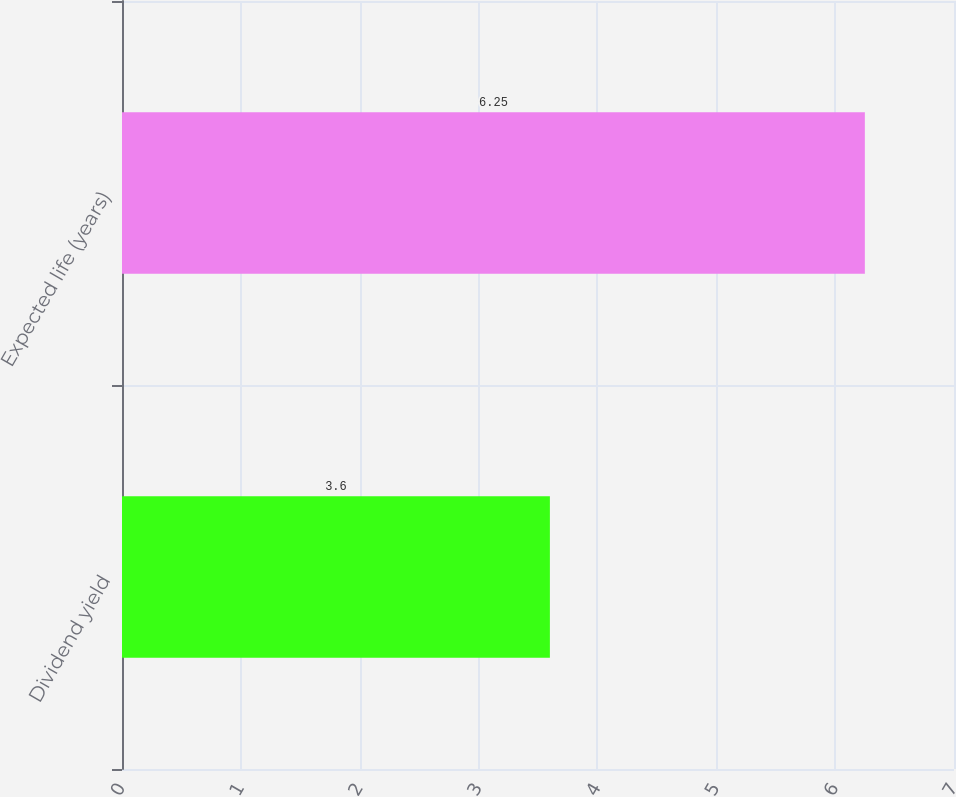Convert chart to OTSL. <chart><loc_0><loc_0><loc_500><loc_500><bar_chart><fcel>Dividend yield<fcel>Expected life (years)<nl><fcel>3.6<fcel>6.25<nl></chart> 